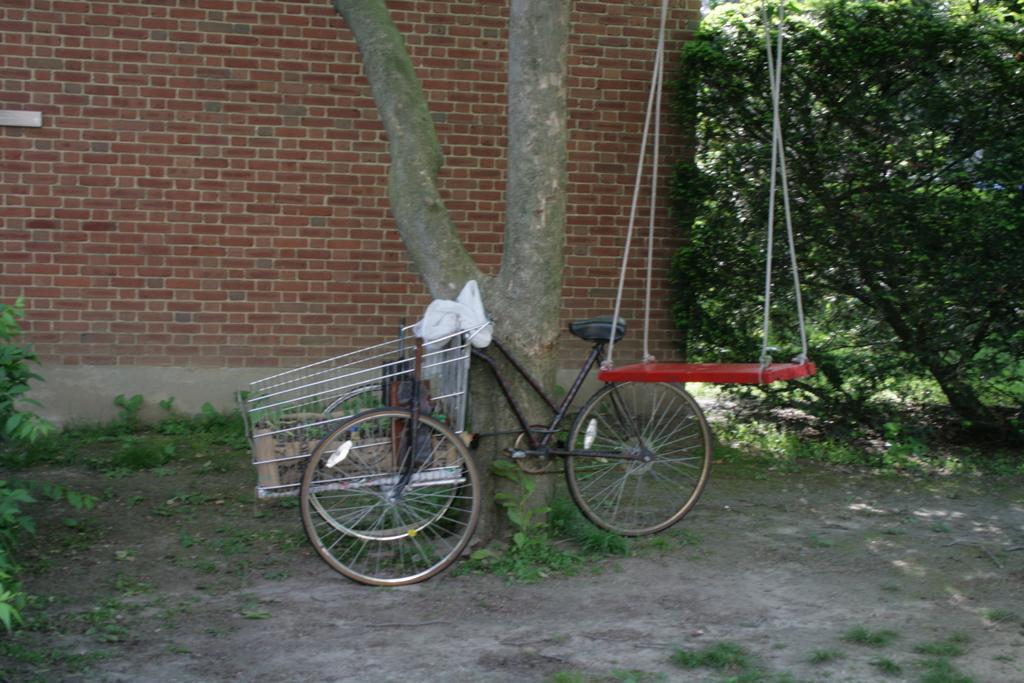In one or two sentences, can you explain what this image depicts? In the middle of this image there is a tree trunk, bicycle, trolley and a swing. At the bottom, I can see the plants on the ground. In the background there is a wall. On the right side there is a tree. 